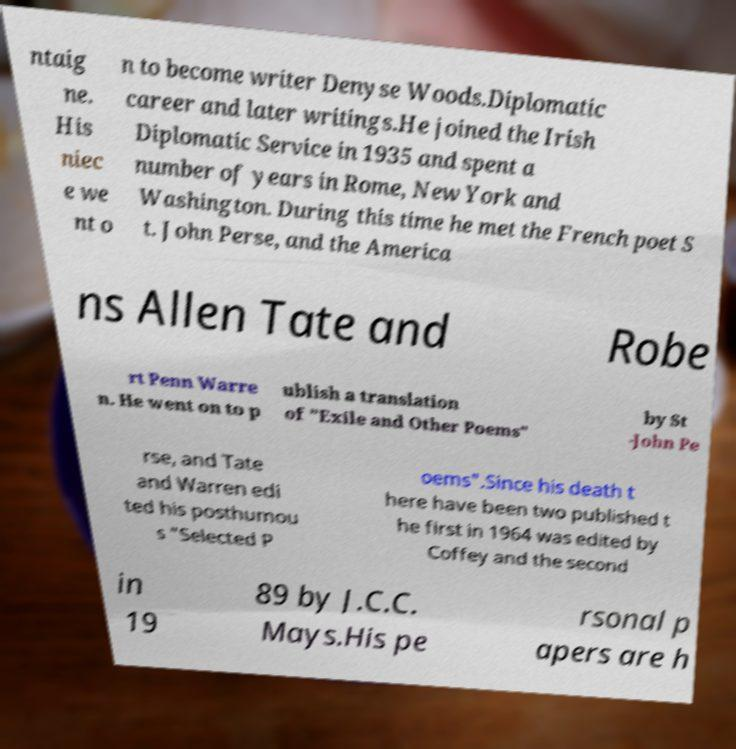There's text embedded in this image that I need extracted. Can you transcribe it verbatim? ntaig ne. His niec e we nt o n to become writer Denyse Woods.Diplomatic career and later writings.He joined the Irish Diplomatic Service in 1935 and spent a number of years in Rome, New York and Washington. During this time he met the French poet S t. John Perse, and the America ns Allen Tate and Robe rt Penn Warre n. He went on to p ublish a translation of "Exile and Other Poems" by St -John Pe rse, and Tate and Warren edi ted his posthumou s "Selected P oems".Since his death t here have been two published t he first in 1964 was edited by Coffey and the second in 19 89 by J.C.C. Mays.His pe rsonal p apers are h 